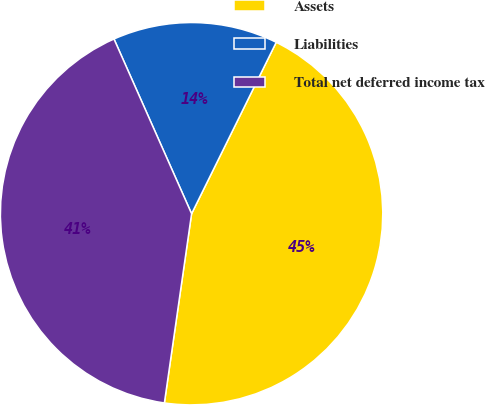Convert chart. <chart><loc_0><loc_0><loc_500><loc_500><pie_chart><fcel>Assets<fcel>Liabilities<fcel>Total net deferred income tax<nl><fcel>44.97%<fcel>13.95%<fcel>41.07%<nl></chart> 